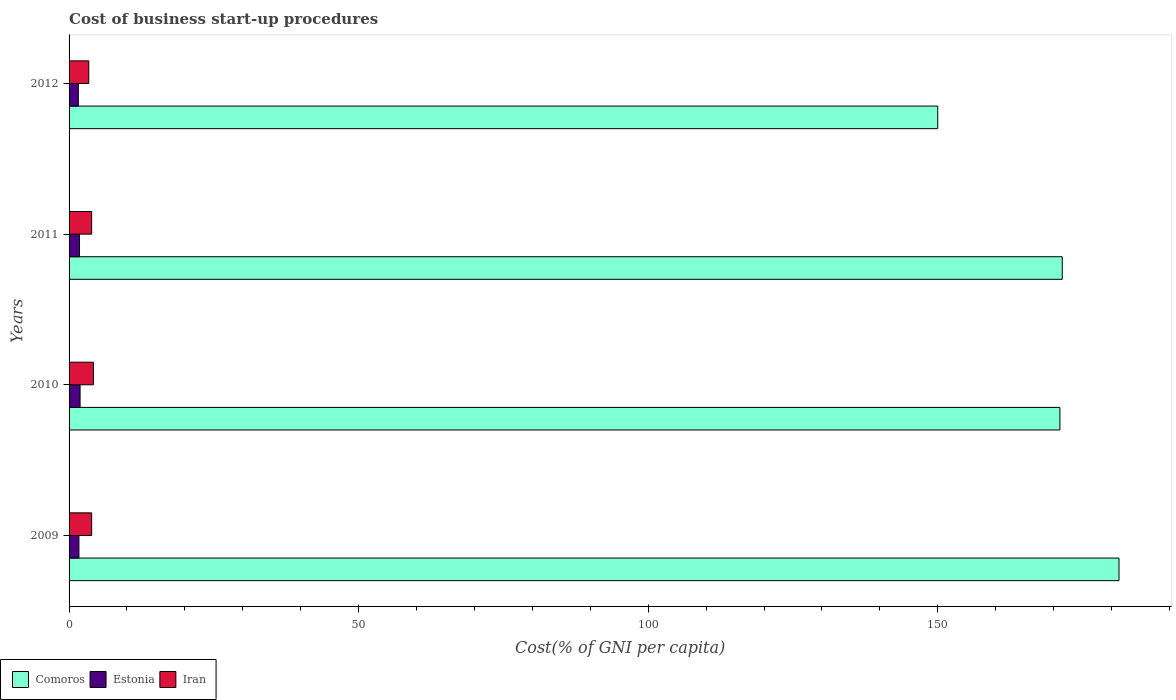How many different coloured bars are there?
Offer a very short reply. 3. Are the number of bars on each tick of the Y-axis equal?
Offer a terse response. Yes. How many bars are there on the 4th tick from the bottom?
Your answer should be compact. 3. What is the label of the 2nd group of bars from the top?
Provide a short and direct response. 2011. What is the cost of business start-up procedures in Iran in 2010?
Ensure brevity in your answer.  4.2. Across all years, what is the maximum cost of business start-up procedures in Comoros?
Your answer should be compact. 181.3. Across all years, what is the minimum cost of business start-up procedures in Estonia?
Ensure brevity in your answer.  1.6. In which year was the cost of business start-up procedures in Comoros minimum?
Make the answer very short. 2012. What is the difference between the cost of business start-up procedures in Estonia in 2011 and that in 2012?
Offer a very short reply. 0.2. What is the difference between the cost of business start-up procedures in Estonia in 2009 and the cost of business start-up procedures in Comoros in 2012?
Ensure brevity in your answer.  -148.3. In the year 2011, what is the difference between the cost of business start-up procedures in Comoros and cost of business start-up procedures in Estonia?
Offer a terse response. 169.7. In how many years, is the cost of business start-up procedures in Comoros greater than 90 %?
Your answer should be very brief. 4. What is the ratio of the cost of business start-up procedures in Iran in 2010 to that in 2012?
Make the answer very short. 1.24. What is the difference between the highest and the second highest cost of business start-up procedures in Estonia?
Keep it short and to the point. 0.1. What is the difference between the highest and the lowest cost of business start-up procedures in Comoros?
Offer a very short reply. 31.3. In how many years, is the cost of business start-up procedures in Comoros greater than the average cost of business start-up procedures in Comoros taken over all years?
Your response must be concise. 3. What does the 2nd bar from the top in 2012 represents?
Make the answer very short. Estonia. What does the 2nd bar from the bottom in 2011 represents?
Your answer should be very brief. Estonia. How many years are there in the graph?
Your answer should be compact. 4. Are the values on the major ticks of X-axis written in scientific E-notation?
Your answer should be compact. No. Does the graph contain any zero values?
Ensure brevity in your answer.  No. Does the graph contain grids?
Your answer should be very brief. No. Where does the legend appear in the graph?
Your response must be concise. Bottom left. How many legend labels are there?
Offer a very short reply. 3. How are the legend labels stacked?
Keep it short and to the point. Horizontal. What is the title of the graph?
Your answer should be compact. Cost of business start-up procedures. Does "Other small states" appear as one of the legend labels in the graph?
Provide a short and direct response. No. What is the label or title of the X-axis?
Provide a succinct answer. Cost(% of GNI per capita). What is the Cost(% of GNI per capita) of Comoros in 2009?
Your answer should be very brief. 181.3. What is the Cost(% of GNI per capita) in Estonia in 2009?
Your response must be concise. 1.7. What is the Cost(% of GNI per capita) of Comoros in 2010?
Your response must be concise. 171.1. What is the Cost(% of GNI per capita) in Estonia in 2010?
Your answer should be very brief. 1.9. What is the Cost(% of GNI per capita) in Iran in 2010?
Ensure brevity in your answer.  4.2. What is the Cost(% of GNI per capita) of Comoros in 2011?
Your answer should be very brief. 171.5. What is the Cost(% of GNI per capita) in Iran in 2011?
Your answer should be very brief. 3.9. What is the Cost(% of GNI per capita) in Comoros in 2012?
Provide a short and direct response. 150. Across all years, what is the maximum Cost(% of GNI per capita) of Comoros?
Your response must be concise. 181.3. Across all years, what is the maximum Cost(% of GNI per capita) in Estonia?
Provide a succinct answer. 1.9. Across all years, what is the minimum Cost(% of GNI per capita) in Comoros?
Give a very brief answer. 150. Across all years, what is the minimum Cost(% of GNI per capita) of Estonia?
Keep it short and to the point. 1.6. Across all years, what is the minimum Cost(% of GNI per capita) in Iran?
Your answer should be very brief. 3.4. What is the total Cost(% of GNI per capita) of Comoros in the graph?
Ensure brevity in your answer.  673.9. What is the total Cost(% of GNI per capita) of Estonia in the graph?
Your response must be concise. 7. What is the difference between the Cost(% of GNI per capita) in Comoros in 2009 and that in 2010?
Make the answer very short. 10.2. What is the difference between the Cost(% of GNI per capita) of Iran in 2009 and that in 2010?
Offer a very short reply. -0.3. What is the difference between the Cost(% of GNI per capita) in Estonia in 2009 and that in 2011?
Give a very brief answer. -0.1. What is the difference between the Cost(% of GNI per capita) in Comoros in 2009 and that in 2012?
Give a very brief answer. 31.3. What is the difference between the Cost(% of GNI per capita) in Estonia in 2009 and that in 2012?
Provide a succinct answer. 0.1. What is the difference between the Cost(% of GNI per capita) in Iran in 2009 and that in 2012?
Give a very brief answer. 0.5. What is the difference between the Cost(% of GNI per capita) of Comoros in 2010 and that in 2011?
Give a very brief answer. -0.4. What is the difference between the Cost(% of GNI per capita) of Comoros in 2010 and that in 2012?
Your answer should be very brief. 21.1. What is the difference between the Cost(% of GNI per capita) in Estonia in 2010 and that in 2012?
Keep it short and to the point. 0.3. What is the difference between the Cost(% of GNI per capita) in Comoros in 2011 and that in 2012?
Your answer should be compact. 21.5. What is the difference between the Cost(% of GNI per capita) of Iran in 2011 and that in 2012?
Give a very brief answer. 0.5. What is the difference between the Cost(% of GNI per capita) of Comoros in 2009 and the Cost(% of GNI per capita) of Estonia in 2010?
Give a very brief answer. 179.4. What is the difference between the Cost(% of GNI per capita) of Comoros in 2009 and the Cost(% of GNI per capita) of Iran in 2010?
Provide a succinct answer. 177.1. What is the difference between the Cost(% of GNI per capita) of Comoros in 2009 and the Cost(% of GNI per capita) of Estonia in 2011?
Keep it short and to the point. 179.5. What is the difference between the Cost(% of GNI per capita) of Comoros in 2009 and the Cost(% of GNI per capita) of Iran in 2011?
Ensure brevity in your answer.  177.4. What is the difference between the Cost(% of GNI per capita) in Estonia in 2009 and the Cost(% of GNI per capita) in Iran in 2011?
Make the answer very short. -2.2. What is the difference between the Cost(% of GNI per capita) in Comoros in 2009 and the Cost(% of GNI per capita) in Estonia in 2012?
Provide a short and direct response. 179.7. What is the difference between the Cost(% of GNI per capita) in Comoros in 2009 and the Cost(% of GNI per capita) in Iran in 2012?
Ensure brevity in your answer.  177.9. What is the difference between the Cost(% of GNI per capita) in Comoros in 2010 and the Cost(% of GNI per capita) in Estonia in 2011?
Give a very brief answer. 169.3. What is the difference between the Cost(% of GNI per capita) in Comoros in 2010 and the Cost(% of GNI per capita) in Iran in 2011?
Your answer should be compact. 167.2. What is the difference between the Cost(% of GNI per capita) of Estonia in 2010 and the Cost(% of GNI per capita) of Iran in 2011?
Keep it short and to the point. -2. What is the difference between the Cost(% of GNI per capita) of Comoros in 2010 and the Cost(% of GNI per capita) of Estonia in 2012?
Make the answer very short. 169.5. What is the difference between the Cost(% of GNI per capita) in Comoros in 2010 and the Cost(% of GNI per capita) in Iran in 2012?
Give a very brief answer. 167.7. What is the difference between the Cost(% of GNI per capita) of Estonia in 2010 and the Cost(% of GNI per capita) of Iran in 2012?
Offer a very short reply. -1.5. What is the difference between the Cost(% of GNI per capita) of Comoros in 2011 and the Cost(% of GNI per capita) of Estonia in 2012?
Give a very brief answer. 169.9. What is the difference between the Cost(% of GNI per capita) in Comoros in 2011 and the Cost(% of GNI per capita) in Iran in 2012?
Give a very brief answer. 168.1. What is the average Cost(% of GNI per capita) in Comoros per year?
Provide a short and direct response. 168.47. What is the average Cost(% of GNI per capita) in Estonia per year?
Your answer should be very brief. 1.75. What is the average Cost(% of GNI per capita) of Iran per year?
Your response must be concise. 3.85. In the year 2009, what is the difference between the Cost(% of GNI per capita) of Comoros and Cost(% of GNI per capita) of Estonia?
Make the answer very short. 179.6. In the year 2009, what is the difference between the Cost(% of GNI per capita) of Comoros and Cost(% of GNI per capita) of Iran?
Offer a terse response. 177.4. In the year 2010, what is the difference between the Cost(% of GNI per capita) of Comoros and Cost(% of GNI per capita) of Estonia?
Keep it short and to the point. 169.2. In the year 2010, what is the difference between the Cost(% of GNI per capita) in Comoros and Cost(% of GNI per capita) in Iran?
Make the answer very short. 166.9. In the year 2010, what is the difference between the Cost(% of GNI per capita) in Estonia and Cost(% of GNI per capita) in Iran?
Offer a very short reply. -2.3. In the year 2011, what is the difference between the Cost(% of GNI per capita) of Comoros and Cost(% of GNI per capita) of Estonia?
Your response must be concise. 169.7. In the year 2011, what is the difference between the Cost(% of GNI per capita) in Comoros and Cost(% of GNI per capita) in Iran?
Make the answer very short. 167.6. In the year 2012, what is the difference between the Cost(% of GNI per capita) of Comoros and Cost(% of GNI per capita) of Estonia?
Your answer should be compact. 148.4. In the year 2012, what is the difference between the Cost(% of GNI per capita) in Comoros and Cost(% of GNI per capita) in Iran?
Offer a very short reply. 146.6. What is the ratio of the Cost(% of GNI per capita) in Comoros in 2009 to that in 2010?
Offer a very short reply. 1.06. What is the ratio of the Cost(% of GNI per capita) of Estonia in 2009 to that in 2010?
Offer a very short reply. 0.89. What is the ratio of the Cost(% of GNI per capita) in Comoros in 2009 to that in 2011?
Give a very brief answer. 1.06. What is the ratio of the Cost(% of GNI per capita) of Iran in 2009 to that in 2011?
Provide a short and direct response. 1. What is the ratio of the Cost(% of GNI per capita) in Comoros in 2009 to that in 2012?
Your answer should be compact. 1.21. What is the ratio of the Cost(% of GNI per capita) of Iran in 2009 to that in 2012?
Make the answer very short. 1.15. What is the ratio of the Cost(% of GNI per capita) in Comoros in 2010 to that in 2011?
Give a very brief answer. 1. What is the ratio of the Cost(% of GNI per capita) in Estonia in 2010 to that in 2011?
Keep it short and to the point. 1.06. What is the ratio of the Cost(% of GNI per capita) of Iran in 2010 to that in 2011?
Ensure brevity in your answer.  1.08. What is the ratio of the Cost(% of GNI per capita) in Comoros in 2010 to that in 2012?
Provide a short and direct response. 1.14. What is the ratio of the Cost(% of GNI per capita) of Estonia in 2010 to that in 2012?
Offer a very short reply. 1.19. What is the ratio of the Cost(% of GNI per capita) in Iran in 2010 to that in 2012?
Ensure brevity in your answer.  1.24. What is the ratio of the Cost(% of GNI per capita) of Comoros in 2011 to that in 2012?
Provide a short and direct response. 1.14. What is the ratio of the Cost(% of GNI per capita) of Estonia in 2011 to that in 2012?
Make the answer very short. 1.12. What is the ratio of the Cost(% of GNI per capita) in Iran in 2011 to that in 2012?
Your response must be concise. 1.15. What is the difference between the highest and the second highest Cost(% of GNI per capita) of Estonia?
Provide a short and direct response. 0.1. What is the difference between the highest and the second highest Cost(% of GNI per capita) in Iran?
Offer a terse response. 0.3. What is the difference between the highest and the lowest Cost(% of GNI per capita) of Comoros?
Ensure brevity in your answer.  31.3. What is the difference between the highest and the lowest Cost(% of GNI per capita) in Estonia?
Your answer should be compact. 0.3. What is the difference between the highest and the lowest Cost(% of GNI per capita) in Iran?
Make the answer very short. 0.8. 